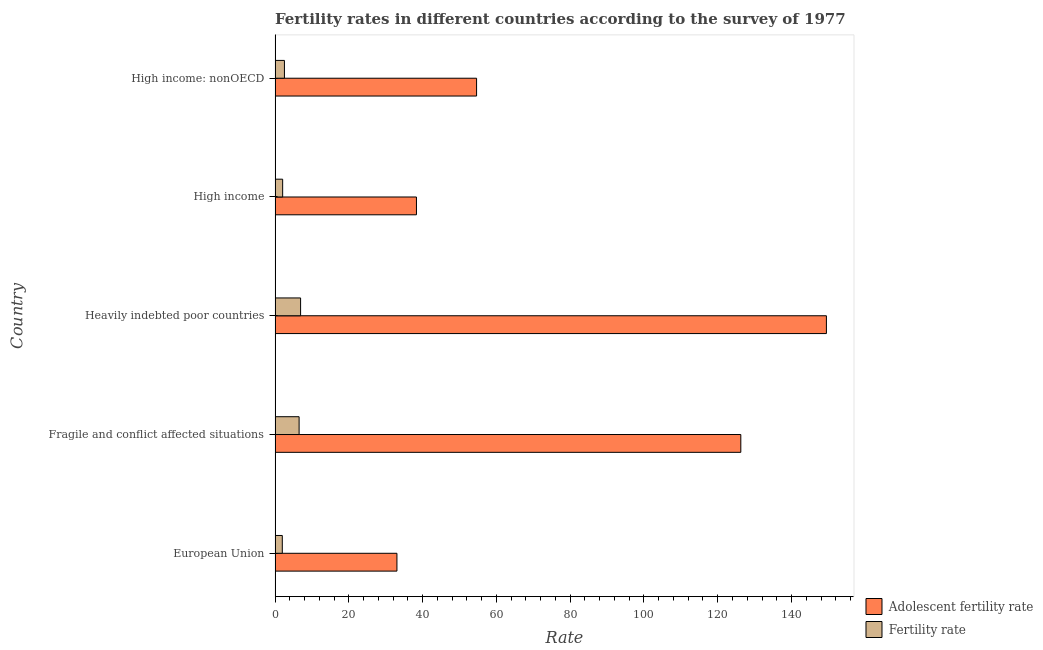Are the number of bars on each tick of the Y-axis equal?
Provide a short and direct response. Yes. How many bars are there on the 5th tick from the top?
Your response must be concise. 2. What is the fertility rate in European Union?
Your response must be concise. 1.96. Across all countries, what is the maximum fertility rate?
Provide a succinct answer. 6.92. Across all countries, what is the minimum adolescent fertility rate?
Keep it short and to the point. 33.04. In which country was the fertility rate maximum?
Offer a very short reply. Heavily indebted poor countries. What is the total fertility rate in the graph?
Offer a terse response. 19.98. What is the difference between the fertility rate in High income and that in High income: nonOECD?
Provide a succinct answer. -0.48. What is the difference between the fertility rate in High income and the adolescent fertility rate in Fragile and conflict affected situations?
Offer a terse response. -124.2. What is the average fertility rate per country?
Your answer should be very brief. 4. What is the difference between the fertility rate and adolescent fertility rate in Fragile and conflict affected situations?
Your answer should be compact. -119.74. What is the ratio of the fertility rate in European Union to that in Heavily indebted poor countries?
Your response must be concise. 0.28. Is the adolescent fertility rate in European Union less than that in High income?
Provide a succinct answer. Yes. What is the difference between the highest and the second highest adolescent fertility rate?
Ensure brevity in your answer.  23.2. What is the difference between the highest and the lowest fertility rate?
Provide a short and direct response. 4.96. What does the 1st bar from the top in High income: nonOECD represents?
Offer a very short reply. Fertility rate. What does the 2nd bar from the bottom in High income represents?
Your answer should be compact. Fertility rate. How many countries are there in the graph?
Ensure brevity in your answer.  5. Are the values on the major ticks of X-axis written in scientific E-notation?
Make the answer very short. No. Does the graph contain any zero values?
Your answer should be compact. No. Does the graph contain grids?
Ensure brevity in your answer.  No. Where does the legend appear in the graph?
Give a very brief answer. Bottom right. How many legend labels are there?
Provide a short and direct response. 2. What is the title of the graph?
Offer a terse response. Fertility rates in different countries according to the survey of 1977. Does "Not attending school" appear as one of the legend labels in the graph?
Make the answer very short. No. What is the label or title of the X-axis?
Offer a very short reply. Rate. What is the label or title of the Y-axis?
Give a very brief answer. Country. What is the Rate in Adolescent fertility rate in European Union?
Your response must be concise. 33.04. What is the Rate of Fertility rate in European Union?
Offer a very short reply. 1.96. What is the Rate in Adolescent fertility rate in Fragile and conflict affected situations?
Offer a very short reply. 126.26. What is the Rate in Fertility rate in Fragile and conflict affected situations?
Offer a very short reply. 6.52. What is the Rate of Adolescent fertility rate in Heavily indebted poor countries?
Give a very brief answer. 149.46. What is the Rate of Fertility rate in Heavily indebted poor countries?
Your response must be concise. 6.92. What is the Rate of Adolescent fertility rate in High income?
Provide a short and direct response. 38.32. What is the Rate in Fertility rate in High income?
Keep it short and to the point. 2.06. What is the Rate of Adolescent fertility rate in High income: nonOECD?
Give a very brief answer. 54.63. What is the Rate in Fertility rate in High income: nonOECD?
Give a very brief answer. 2.54. Across all countries, what is the maximum Rate in Adolescent fertility rate?
Make the answer very short. 149.46. Across all countries, what is the maximum Rate in Fertility rate?
Your answer should be very brief. 6.92. Across all countries, what is the minimum Rate in Adolescent fertility rate?
Ensure brevity in your answer.  33.04. Across all countries, what is the minimum Rate of Fertility rate?
Your response must be concise. 1.96. What is the total Rate in Adolescent fertility rate in the graph?
Offer a terse response. 401.71. What is the total Rate of Fertility rate in the graph?
Your answer should be compact. 19.98. What is the difference between the Rate of Adolescent fertility rate in European Union and that in Fragile and conflict affected situations?
Your answer should be very brief. -93.22. What is the difference between the Rate in Fertility rate in European Union and that in Fragile and conflict affected situations?
Give a very brief answer. -4.56. What is the difference between the Rate of Adolescent fertility rate in European Union and that in Heavily indebted poor countries?
Keep it short and to the point. -116.43. What is the difference between the Rate in Fertility rate in European Union and that in Heavily indebted poor countries?
Your response must be concise. -4.96. What is the difference between the Rate of Adolescent fertility rate in European Union and that in High income?
Keep it short and to the point. -5.29. What is the difference between the Rate in Fertility rate in European Union and that in High income?
Provide a succinct answer. -0.1. What is the difference between the Rate of Adolescent fertility rate in European Union and that in High income: nonOECD?
Your answer should be very brief. -21.59. What is the difference between the Rate in Fertility rate in European Union and that in High income: nonOECD?
Make the answer very short. -0.58. What is the difference between the Rate in Adolescent fertility rate in Fragile and conflict affected situations and that in Heavily indebted poor countries?
Keep it short and to the point. -23.2. What is the difference between the Rate of Fertility rate in Fragile and conflict affected situations and that in Heavily indebted poor countries?
Give a very brief answer. -0.4. What is the difference between the Rate of Adolescent fertility rate in Fragile and conflict affected situations and that in High income?
Give a very brief answer. 87.93. What is the difference between the Rate of Fertility rate in Fragile and conflict affected situations and that in High income?
Provide a succinct answer. 4.46. What is the difference between the Rate of Adolescent fertility rate in Fragile and conflict affected situations and that in High income: nonOECD?
Offer a terse response. 71.63. What is the difference between the Rate in Fertility rate in Fragile and conflict affected situations and that in High income: nonOECD?
Make the answer very short. 3.98. What is the difference between the Rate in Adolescent fertility rate in Heavily indebted poor countries and that in High income?
Offer a very short reply. 111.14. What is the difference between the Rate in Fertility rate in Heavily indebted poor countries and that in High income?
Make the answer very short. 4.86. What is the difference between the Rate of Adolescent fertility rate in Heavily indebted poor countries and that in High income: nonOECD?
Your answer should be very brief. 94.84. What is the difference between the Rate of Fertility rate in Heavily indebted poor countries and that in High income: nonOECD?
Keep it short and to the point. 4.38. What is the difference between the Rate in Adolescent fertility rate in High income and that in High income: nonOECD?
Your answer should be very brief. -16.3. What is the difference between the Rate of Fertility rate in High income and that in High income: nonOECD?
Provide a short and direct response. -0.48. What is the difference between the Rate in Adolescent fertility rate in European Union and the Rate in Fertility rate in Fragile and conflict affected situations?
Offer a terse response. 26.52. What is the difference between the Rate of Adolescent fertility rate in European Union and the Rate of Fertility rate in Heavily indebted poor countries?
Offer a terse response. 26.12. What is the difference between the Rate of Adolescent fertility rate in European Union and the Rate of Fertility rate in High income?
Your answer should be compact. 30.98. What is the difference between the Rate of Adolescent fertility rate in European Union and the Rate of Fertility rate in High income: nonOECD?
Provide a succinct answer. 30.5. What is the difference between the Rate of Adolescent fertility rate in Fragile and conflict affected situations and the Rate of Fertility rate in Heavily indebted poor countries?
Offer a terse response. 119.34. What is the difference between the Rate in Adolescent fertility rate in Fragile and conflict affected situations and the Rate in Fertility rate in High income?
Provide a short and direct response. 124.2. What is the difference between the Rate of Adolescent fertility rate in Fragile and conflict affected situations and the Rate of Fertility rate in High income: nonOECD?
Ensure brevity in your answer.  123.72. What is the difference between the Rate of Adolescent fertility rate in Heavily indebted poor countries and the Rate of Fertility rate in High income?
Ensure brevity in your answer.  147.41. What is the difference between the Rate of Adolescent fertility rate in Heavily indebted poor countries and the Rate of Fertility rate in High income: nonOECD?
Your response must be concise. 146.93. What is the difference between the Rate of Adolescent fertility rate in High income and the Rate of Fertility rate in High income: nonOECD?
Provide a short and direct response. 35.79. What is the average Rate in Adolescent fertility rate per country?
Provide a succinct answer. 80.34. What is the average Rate in Fertility rate per country?
Your answer should be compact. 4. What is the difference between the Rate in Adolescent fertility rate and Rate in Fertility rate in European Union?
Ensure brevity in your answer.  31.08. What is the difference between the Rate in Adolescent fertility rate and Rate in Fertility rate in Fragile and conflict affected situations?
Make the answer very short. 119.74. What is the difference between the Rate in Adolescent fertility rate and Rate in Fertility rate in Heavily indebted poor countries?
Your response must be concise. 142.55. What is the difference between the Rate of Adolescent fertility rate and Rate of Fertility rate in High income?
Keep it short and to the point. 36.27. What is the difference between the Rate of Adolescent fertility rate and Rate of Fertility rate in High income: nonOECD?
Offer a terse response. 52.09. What is the ratio of the Rate in Adolescent fertility rate in European Union to that in Fragile and conflict affected situations?
Ensure brevity in your answer.  0.26. What is the ratio of the Rate in Fertility rate in European Union to that in Fragile and conflict affected situations?
Ensure brevity in your answer.  0.3. What is the ratio of the Rate in Adolescent fertility rate in European Union to that in Heavily indebted poor countries?
Keep it short and to the point. 0.22. What is the ratio of the Rate in Fertility rate in European Union to that in Heavily indebted poor countries?
Your answer should be compact. 0.28. What is the ratio of the Rate in Adolescent fertility rate in European Union to that in High income?
Your answer should be compact. 0.86. What is the ratio of the Rate in Fertility rate in European Union to that in High income?
Keep it short and to the point. 0.95. What is the ratio of the Rate of Adolescent fertility rate in European Union to that in High income: nonOECD?
Make the answer very short. 0.6. What is the ratio of the Rate of Fertility rate in European Union to that in High income: nonOECD?
Make the answer very short. 0.77. What is the ratio of the Rate of Adolescent fertility rate in Fragile and conflict affected situations to that in Heavily indebted poor countries?
Your response must be concise. 0.84. What is the ratio of the Rate in Fertility rate in Fragile and conflict affected situations to that in Heavily indebted poor countries?
Offer a very short reply. 0.94. What is the ratio of the Rate in Adolescent fertility rate in Fragile and conflict affected situations to that in High income?
Give a very brief answer. 3.29. What is the ratio of the Rate of Fertility rate in Fragile and conflict affected situations to that in High income?
Keep it short and to the point. 3.17. What is the ratio of the Rate of Adolescent fertility rate in Fragile and conflict affected situations to that in High income: nonOECD?
Your response must be concise. 2.31. What is the ratio of the Rate in Fertility rate in Fragile and conflict affected situations to that in High income: nonOECD?
Make the answer very short. 2.57. What is the ratio of the Rate of Adolescent fertility rate in Heavily indebted poor countries to that in High income?
Provide a succinct answer. 3.9. What is the ratio of the Rate in Fertility rate in Heavily indebted poor countries to that in High income?
Your response must be concise. 3.37. What is the ratio of the Rate in Adolescent fertility rate in Heavily indebted poor countries to that in High income: nonOECD?
Offer a terse response. 2.74. What is the ratio of the Rate of Fertility rate in Heavily indebted poor countries to that in High income: nonOECD?
Provide a short and direct response. 2.73. What is the ratio of the Rate of Adolescent fertility rate in High income to that in High income: nonOECD?
Offer a very short reply. 0.7. What is the ratio of the Rate in Fertility rate in High income to that in High income: nonOECD?
Provide a short and direct response. 0.81. What is the difference between the highest and the second highest Rate of Adolescent fertility rate?
Your response must be concise. 23.2. What is the difference between the highest and the second highest Rate in Fertility rate?
Your response must be concise. 0.4. What is the difference between the highest and the lowest Rate of Adolescent fertility rate?
Ensure brevity in your answer.  116.43. What is the difference between the highest and the lowest Rate of Fertility rate?
Provide a short and direct response. 4.96. 